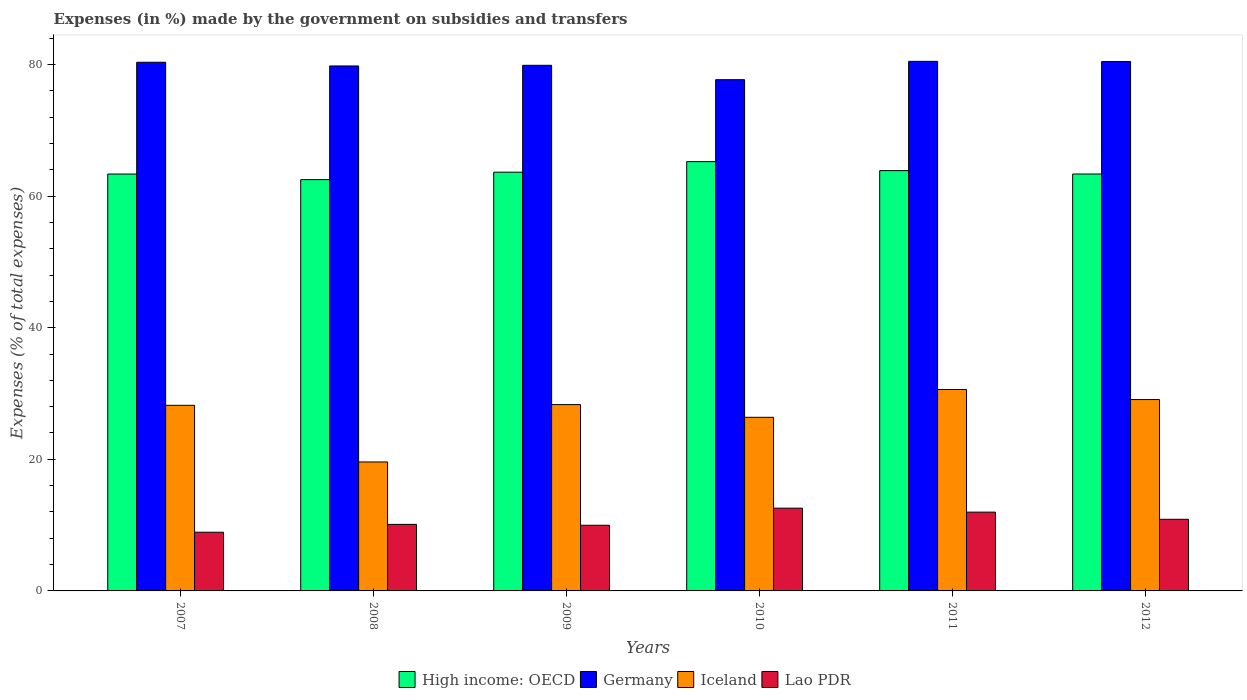How many different coloured bars are there?
Offer a terse response. 4. Are the number of bars on each tick of the X-axis equal?
Your answer should be compact. Yes. How many bars are there on the 1st tick from the right?
Provide a short and direct response. 4. What is the percentage of expenses made by the government on subsidies and transfers in Lao PDR in 2007?
Your response must be concise. 8.92. Across all years, what is the maximum percentage of expenses made by the government on subsidies and transfers in Lao PDR?
Offer a very short reply. 12.58. Across all years, what is the minimum percentage of expenses made by the government on subsidies and transfers in High income: OECD?
Give a very brief answer. 62.5. What is the total percentage of expenses made by the government on subsidies and transfers in High income: OECD in the graph?
Provide a short and direct response. 381.93. What is the difference between the percentage of expenses made by the government on subsidies and transfers in Germany in 2010 and that in 2012?
Your response must be concise. -2.76. What is the difference between the percentage of expenses made by the government on subsidies and transfers in High income: OECD in 2007 and the percentage of expenses made by the government on subsidies and transfers in Lao PDR in 2012?
Your answer should be very brief. 52.46. What is the average percentage of expenses made by the government on subsidies and transfers in Germany per year?
Offer a very short reply. 79.76. In the year 2011, what is the difference between the percentage of expenses made by the government on subsidies and transfers in Iceland and percentage of expenses made by the government on subsidies and transfers in Lao PDR?
Make the answer very short. 18.63. In how many years, is the percentage of expenses made by the government on subsidies and transfers in Iceland greater than 16 %?
Ensure brevity in your answer.  6. What is the ratio of the percentage of expenses made by the government on subsidies and transfers in High income: OECD in 2007 to that in 2011?
Offer a very short reply. 0.99. What is the difference between the highest and the second highest percentage of expenses made by the government on subsidies and transfers in High income: OECD?
Offer a terse response. 1.37. What is the difference between the highest and the lowest percentage of expenses made by the government on subsidies and transfers in High income: OECD?
Your answer should be very brief. 2.73. In how many years, is the percentage of expenses made by the government on subsidies and transfers in Germany greater than the average percentage of expenses made by the government on subsidies and transfers in Germany taken over all years?
Offer a terse response. 5. Is it the case that in every year, the sum of the percentage of expenses made by the government on subsidies and transfers in Iceland and percentage of expenses made by the government on subsidies and transfers in Lao PDR is greater than the sum of percentage of expenses made by the government on subsidies and transfers in Germany and percentage of expenses made by the government on subsidies and transfers in High income: OECD?
Keep it short and to the point. Yes. What does the 1st bar from the left in 2009 represents?
Provide a short and direct response. High income: OECD. What does the 4th bar from the right in 2008 represents?
Your response must be concise. High income: OECD. Is it the case that in every year, the sum of the percentage of expenses made by the government on subsidies and transfers in Germany and percentage of expenses made by the government on subsidies and transfers in Iceland is greater than the percentage of expenses made by the government on subsidies and transfers in High income: OECD?
Offer a terse response. Yes. How many years are there in the graph?
Provide a short and direct response. 6. What is the difference between two consecutive major ticks on the Y-axis?
Provide a succinct answer. 20. Are the values on the major ticks of Y-axis written in scientific E-notation?
Give a very brief answer. No. Does the graph contain any zero values?
Offer a very short reply. No. How are the legend labels stacked?
Keep it short and to the point. Horizontal. What is the title of the graph?
Keep it short and to the point. Expenses (in %) made by the government on subsidies and transfers. Does "Seychelles" appear as one of the legend labels in the graph?
Your response must be concise. No. What is the label or title of the Y-axis?
Provide a short and direct response. Expenses (% of total expenses). What is the Expenses (% of total expenses) in High income: OECD in 2007?
Your answer should be very brief. 63.35. What is the Expenses (% of total expenses) in Germany in 2007?
Your response must be concise. 80.33. What is the Expenses (% of total expenses) in Iceland in 2007?
Provide a short and direct response. 28.2. What is the Expenses (% of total expenses) in Lao PDR in 2007?
Provide a succinct answer. 8.92. What is the Expenses (% of total expenses) in High income: OECD in 2008?
Your answer should be compact. 62.5. What is the Expenses (% of total expenses) in Germany in 2008?
Provide a short and direct response. 79.77. What is the Expenses (% of total expenses) of Iceland in 2008?
Provide a succinct answer. 19.6. What is the Expenses (% of total expenses) in Lao PDR in 2008?
Your response must be concise. 10.11. What is the Expenses (% of total expenses) in High income: OECD in 2009?
Offer a terse response. 63.63. What is the Expenses (% of total expenses) of Germany in 2009?
Ensure brevity in your answer.  79.87. What is the Expenses (% of total expenses) in Iceland in 2009?
Give a very brief answer. 28.31. What is the Expenses (% of total expenses) of Lao PDR in 2009?
Your response must be concise. 9.98. What is the Expenses (% of total expenses) of High income: OECD in 2010?
Give a very brief answer. 65.23. What is the Expenses (% of total expenses) of Germany in 2010?
Offer a terse response. 77.69. What is the Expenses (% of total expenses) of Iceland in 2010?
Keep it short and to the point. 26.38. What is the Expenses (% of total expenses) of Lao PDR in 2010?
Your response must be concise. 12.58. What is the Expenses (% of total expenses) of High income: OECD in 2011?
Give a very brief answer. 63.87. What is the Expenses (% of total expenses) in Germany in 2011?
Provide a succinct answer. 80.47. What is the Expenses (% of total expenses) of Iceland in 2011?
Your answer should be very brief. 30.61. What is the Expenses (% of total expenses) in Lao PDR in 2011?
Offer a very short reply. 11.97. What is the Expenses (% of total expenses) of High income: OECD in 2012?
Provide a short and direct response. 63.35. What is the Expenses (% of total expenses) in Germany in 2012?
Offer a terse response. 80.44. What is the Expenses (% of total expenses) of Iceland in 2012?
Your answer should be compact. 29.08. What is the Expenses (% of total expenses) in Lao PDR in 2012?
Your answer should be very brief. 10.88. Across all years, what is the maximum Expenses (% of total expenses) in High income: OECD?
Make the answer very short. 65.23. Across all years, what is the maximum Expenses (% of total expenses) of Germany?
Make the answer very short. 80.47. Across all years, what is the maximum Expenses (% of total expenses) in Iceland?
Your response must be concise. 30.61. Across all years, what is the maximum Expenses (% of total expenses) in Lao PDR?
Offer a terse response. 12.58. Across all years, what is the minimum Expenses (% of total expenses) in High income: OECD?
Keep it short and to the point. 62.5. Across all years, what is the minimum Expenses (% of total expenses) of Germany?
Keep it short and to the point. 77.69. Across all years, what is the minimum Expenses (% of total expenses) in Iceland?
Provide a succinct answer. 19.6. Across all years, what is the minimum Expenses (% of total expenses) in Lao PDR?
Provide a short and direct response. 8.92. What is the total Expenses (% of total expenses) of High income: OECD in the graph?
Keep it short and to the point. 381.93. What is the total Expenses (% of total expenses) in Germany in the graph?
Offer a very short reply. 478.57. What is the total Expenses (% of total expenses) of Iceland in the graph?
Your answer should be compact. 162.18. What is the total Expenses (% of total expenses) in Lao PDR in the graph?
Provide a succinct answer. 64.44. What is the difference between the Expenses (% of total expenses) in High income: OECD in 2007 and that in 2008?
Your answer should be very brief. 0.85. What is the difference between the Expenses (% of total expenses) in Germany in 2007 and that in 2008?
Make the answer very short. 0.56. What is the difference between the Expenses (% of total expenses) of Iceland in 2007 and that in 2008?
Your response must be concise. 8.61. What is the difference between the Expenses (% of total expenses) of Lao PDR in 2007 and that in 2008?
Provide a succinct answer. -1.19. What is the difference between the Expenses (% of total expenses) of High income: OECD in 2007 and that in 2009?
Keep it short and to the point. -0.28. What is the difference between the Expenses (% of total expenses) of Germany in 2007 and that in 2009?
Keep it short and to the point. 0.46. What is the difference between the Expenses (% of total expenses) of Iceland in 2007 and that in 2009?
Provide a short and direct response. -0.11. What is the difference between the Expenses (% of total expenses) of Lao PDR in 2007 and that in 2009?
Keep it short and to the point. -1.06. What is the difference between the Expenses (% of total expenses) of High income: OECD in 2007 and that in 2010?
Ensure brevity in your answer.  -1.89. What is the difference between the Expenses (% of total expenses) of Germany in 2007 and that in 2010?
Make the answer very short. 2.65. What is the difference between the Expenses (% of total expenses) in Iceland in 2007 and that in 2010?
Keep it short and to the point. 1.82. What is the difference between the Expenses (% of total expenses) of Lao PDR in 2007 and that in 2010?
Offer a terse response. -3.66. What is the difference between the Expenses (% of total expenses) of High income: OECD in 2007 and that in 2011?
Keep it short and to the point. -0.52. What is the difference between the Expenses (% of total expenses) of Germany in 2007 and that in 2011?
Make the answer very short. -0.14. What is the difference between the Expenses (% of total expenses) of Iceland in 2007 and that in 2011?
Provide a short and direct response. -2.4. What is the difference between the Expenses (% of total expenses) in Lao PDR in 2007 and that in 2011?
Your response must be concise. -3.05. What is the difference between the Expenses (% of total expenses) in High income: OECD in 2007 and that in 2012?
Provide a short and direct response. -0.01. What is the difference between the Expenses (% of total expenses) of Germany in 2007 and that in 2012?
Your answer should be compact. -0.11. What is the difference between the Expenses (% of total expenses) in Iceland in 2007 and that in 2012?
Your response must be concise. -0.88. What is the difference between the Expenses (% of total expenses) of Lao PDR in 2007 and that in 2012?
Make the answer very short. -1.97. What is the difference between the Expenses (% of total expenses) in High income: OECD in 2008 and that in 2009?
Your answer should be compact. -1.13. What is the difference between the Expenses (% of total expenses) in Germany in 2008 and that in 2009?
Give a very brief answer. -0.1. What is the difference between the Expenses (% of total expenses) of Iceland in 2008 and that in 2009?
Your response must be concise. -8.72. What is the difference between the Expenses (% of total expenses) of Lao PDR in 2008 and that in 2009?
Your answer should be compact. 0.13. What is the difference between the Expenses (% of total expenses) in High income: OECD in 2008 and that in 2010?
Keep it short and to the point. -2.73. What is the difference between the Expenses (% of total expenses) of Germany in 2008 and that in 2010?
Make the answer very short. 2.08. What is the difference between the Expenses (% of total expenses) of Iceland in 2008 and that in 2010?
Give a very brief answer. -6.79. What is the difference between the Expenses (% of total expenses) in Lao PDR in 2008 and that in 2010?
Ensure brevity in your answer.  -2.46. What is the difference between the Expenses (% of total expenses) of High income: OECD in 2008 and that in 2011?
Keep it short and to the point. -1.37. What is the difference between the Expenses (% of total expenses) in Germany in 2008 and that in 2011?
Provide a succinct answer. -0.7. What is the difference between the Expenses (% of total expenses) in Iceland in 2008 and that in 2011?
Offer a terse response. -11.01. What is the difference between the Expenses (% of total expenses) in Lao PDR in 2008 and that in 2011?
Offer a very short reply. -1.86. What is the difference between the Expenses (% of total expenses) in High income: OECD in 2008 and that in 2012?
Provide a succinct answer. -0.85. What is the difference between the Expenses (% of total expenses) of Germany in 2008 and that in 2012?
Ensure brevity in your answer.  -0.67. What is the difference between the Expenses (% of total expenses) in Iceland in 2008 and that in 2012?
Provide a short and direct response. -9.48. What is the difference between the Expenses (% of total expenses) of Lao PDR in 2008 and that in 2012?
Your answer should be compact. -0.77. What is the difference between the Expenses (% of total expenses) of High income: OECD in 2009 and that in 2010?
Your answer should be very brief. -1.6. What is the difference between the Expenses (% of total expenses) in Germany in 2009 and that in 2010?
Give a very brief answer. 2.18. What is the difference between the Expenses (% of total expenses) of Iceland in 2009 and that in 2010?
Ensure brevity in your answer.  1.93. What is the difference between the Expenses (% of total expenses) in Lao PDR in 2009 and that in 2010?
Your answer should be very brief. -2.6. What is the difference between the Expenses (% of total expenses) of High income: OECD in 2009 and that in 2011?
Provide a short and direct response. -0.24. What is the difference between the Expenses (% of total expenses) in Germany in 2009 and that in 2011?
Ensure brevity in your answer.  -0.6. What is the difference between the Expenses (% of total expenses) of Iceland in 2009 and that in 2011?
Your response must be concise. -2.29. What is the difference between the Expenses (% of total expenses) of Lao PDR in 2009 and that in 2011?
Offer a very short reply. -1.99. What is the difference between the Expenses (% of total expenses) of High income: OECD in 2009 and that in 2012?
Make the answer very short. 0.28. What is the difference between the Expenses (% of total expenses) in Germany in 2009 and that in 2012?
Give a very brief answer. -0.57. What is the difference between the Expenses (% of total expenses) of Iceland in 2009 and that in 2012?
Ensure brevity in your answer.  -0.77. What is the difference between the Expenses (% of total expenses) in Lao PDR in 2009 and that in 2012?
Your answer should be very brief. -0.91. What is the difference between the Expenses (% of total expenses) in High income: OECD in 2010 and that in 2011?
Give a very brief answer. 1.37. What is the difference between the Expenses (% of total expenses) of Germany in 2010 and that in 2011?
Offer a terse response. -2.78. What is the difference between the Expenses (% of total expenses) in Iceland in 2010 and that in 2011?
Ensure brevity in your answer.  -4.22. What is the difference between the Expenses (% of total expenses) in Lao PDR in 2010 and that in 2011?
Your answer should be compact. 0.6. What is the difference between the Expenses (% of total expenses) in High income: OECD in 2010 and that in 2012?
Provide a succinct answer. 1.88. What is the difference between the Expenses (% of total expenses) in Germany in 2010 and that in 2012?
Offer a very short reply. -2.76. What is the difference between the Expenses (% of total expenses) of Iceland in 2010 and that in 2012?
Give a very brief answer. -2.7. What is the difference between the Expenses (% of total expenses) in Lao PDR in 2010 and that in 2012?
Provide a succinct answer. 1.69. What is the difference between the Expenses (% of total expenses) in High income: OECD in 2011 and that in 2012?
Your response must be concise. 0.51. What is the difference between the Expenses (% of total expenses) in Germany in 2011 and that in 2012?
Give a very brief answer. 0.03. What is the difference between the Expenses (% of total expenses) of Iceland in 2011 and that in 2012?
Provide a short and direct response. 1.53. What is the difference between the Expenses (% of total expenses) in Lao PDR in 2011 and that in 2012?
Provide a short and direct response. 1.09. What is the difference between the Expenses (% of total expenses) in High income: OECD in 2007 and the Expenses (% of total expenses) in Germany in 2008?
Provide a succinct answer. -16.42. What is the difference between the Expenses (% of total expenses) in High income: OECD in 2007 and the Expenses (% of total expenses) in Iceland in 2008?
Make the answer very short. 43.75. What is the difference between the Expenses (% of total expenses) in High income: OECD in 2007 and the Expenses (% of total expenses) in Lao PDR in 2008?
Your answer should be compact. 53.23. What is the difference between the Expenses (% of total expenses) of Germany in 2007 and the Expenses (% of total expenses) of Iceland in 2008?
Offer a very short reply. 60.74. What is the difference between the Expenses (% of total expenses) in Germany in 2007 and the Expenses (% of total expenses) in Lao PDR in 2008?
Give a very brief answer. 70.22. What is the difference between the Expenses (% of total expenses) of Iceland in 2007 and the Expenses (% of total expenses) of Lao PDR in 2008?
Your response must be concise. 18.09. What is the difference between the Expenses (% of total expenses) in High income: OECD in 2007 and the Expenses (% of total expenses) in Germany in 2009?
Make the answer very short. -16.52. What is the difference between the Expenses (% of total expenses) in High income: OECD in 2007 and the Expenses (% of total expenses) in Iceland in 2009?
Your response must be concise. 35.03. What is the difference between the Expenses (% of total expenses) of High income: OECD in 2007 and the Expenses (% of total expenses) of Lao PDR in 2009?
Ensure brevity in your answer.  53.37. What is the difference between the Expenses (% of total expenses) in Germany in 2007 and the Expenses (% of total expenses) in Iceland in 2009?
Offer a very short reply. 52.02. What is the difference between the Expenses (% of total expenses) in Germany in 2007 and the Expenses (% of total expenses) in Lao PDR in 2009?
Ensure brevity in your answer.  70.35. What is the difference between the Expenses (% of total expenses) in Iceland in 2007 and the Expenses (% of total expenses) in Lao PDR in 2009?
Offer a terse response. 18.22. What is the difference between the Expenses (% of total expenses) of High income: OECD in 2007 and the Expenses (% of total expenses) of Germany in 2010?
Ensure brevity in your answer.  -14.34. What is the difference between the Expenses (% of total expenses) of High income: OECD in 2007 and the Expenses (% of total expenses) of Iceland in 2010?
Your answer should be very brief. 36.96. What is the difference between the Expenses (% of total expenses) of High income: OECD in 2007 and the Expenses (% of total expenses) of Lao PDR in 2010?
Provide a succinct answer. 50.77. What is the difference between the Expenses (% of total expenses) of Germany in 2007 and the Expenses (% of total expenses) of Iceland in 2010?
Your answer should be compact. 53.95. What is the difference between the Expenses (% of total expenses) in Germany in 2007 and the Expenses (% of total expenses) in Lao PDR in 2010?
Your answer should be compact. 67.76. What is the difference between the Expenses (% of total expenses) of Iceland in 2007 and the Expenses (% of total expenses) of Lao PDR in 2010?
Make the answer very short. 15.63. What is the difference between the Expenses (% of total expenses) of High income: OECD in 2007 and the Expenses (% of total expenses) of Germany in 2011?
Keep it short and to the point. -17.12. What is the difference between the Expenses (% of total expenses) of High income: OECD in 2007 and the Expenses (% of total expenses) of Iceland in 2011?
Your response must be concise. 32.74. What is the difference between the Expenses (% of total expenses) of High income: OECD in 2007 and the Expenses (% of total expenses) of Lao PDR in 2011?
Offer a terse response. 51.37. What is the difference between the Expenses (% of total expenses) in Germany in 2007 and the Expenses (% of total expenses) in Iceland in 2011?
Provide a short and direct response. 49.73. What is the difference between the Expenses (% of total expenses) in Germany in 2007 and the Expenses (% of total expenses) in Lao PDR in 2011?
Offer a terse response. 68.36. What is the difference between the Expenses (% of total expenses) in Iceland in 2007 and the Expenses (% of total expenses) in Lao PDR in 2011?
Ensure brevity in your answer.  16.23. What is the difference between the Expenses (% of total expenses) in High income: OECD in 2007 and the Expenses (% of total expenses) in Germany in 2012?
Provide a succinct answer. -17.1. What is the difference between the Expenses (% of total expenses) in High income: OECD in 2007 and the Expenses (% of total expenses) in Iceland in 2012?
Your response must be concise. 34.27. What is the difference between the Expenses (% of total expenses) of High income: OECD in 2007 and the Expenses (% of total expenses) of Lao PDR in 2012?
Provide a succinct answer. 52.46. What is the difference between the Expenses (% of total expenses) in Germany in 2007 and the Expenses (% of total expenses) in Iceland in 2012?
Provide a short and direct response. 51.25. What is the difference between the Expenses (% of total expenses) in Germany in 2007 and the Expenses (% of total expenses) in Lao PDR in 2012?
Your answer should be compact. 69.45. What is the difference between the Expenses (% of total expenses) in Iceland in 2007 and the Expenses (% of total expenses) in Lao PDR in 2012?
Your answer should be compact. 17.32. What is the difference between the Expenses (% of total expenses) of High income: OECD in 2008 and the Expenses (% of total expenses) of Germany in 2009?
Make the answer very short. -17.37. What is the difference between the Expenses (% of total expenses) of High income: OECD in 2008 and the Expenses (% of total expenses) of Iceland in 2009?
Provide a succinct answer. 34.19. What is the difference between the Expenses (% of total expenses) in High income: OECD in 2008 and the Expenses (% of total expenses) in Lao PDR in 2009?
Keep it short and to the point. 52.52. What is the difference between the Expenses (% of total expenses) in Germany in 2008 and the Expenses (% of total expenses) in Iceland in 2009?
Provide a short and direct response. 51.46. What is the difference between the Expenses (% of total expenses) of Germany in 2008 and the Expenses (% of total expenses) of Lao PDR in 2009?
Provide a succinct answer. 69.79. What is the difference between the Expenses (% of total expenses) of Iceland in 2008 and the Expenses (% of total expenses) of Lao PDR in 2009?
Your answer should be compact. 9.62. What is the difference between the Expenses (% of total expenses) in High income: OECD in 2008 and the Expenses (% of total expenses) in Germany in 2010?
Ensure brevity in your answer.  -15.19. What is the difference between the Expenses (% of total expenses) in High income: OECD in 2008 and the Expenses (% of total expenses) in Iceland in 2010?
Provide a succinct answer. 36.12. What is the difference between the Expenses (% of total expenses) of High income: OECD in 2008 and the Expenses (% of total expenses) of Lao PDR in 2010?
Offer a very short reply. 49.92. What is the difference between the Expenses (% of total expenses) of Germany in 2008 and the Expenses (% of total expenses) of Iceland in 2010?
Provide a short and direct response. 53.39. What is the difference between the Expenses (% of total expenses) in Germany in 2008 and the Expenses (% of total expenses) in Lao PDR in 2010?
Offer a very short reply. 67.19. What is the difference between the Expenses (% of total expenses) in Iceland in 2008 and the Expenses (% of total expenses) in Lao PDR in 2010?
Offer a very short reply. 7.02. What is the difference between the Expenses (% of total expenses) in High income: OECD in 2008 and the Expenses (% of total expenses) in Germany in 2011?
Ensure brevity in your answer.  -17.97. What is the difference between the Expenses (% of total expenses) of High income: OECD in 2008 and the Expenses (% of total expenses) of Iceland in 2011?
Ensure brevity in your answer.  31.89. What is the difference between the Expenses (% of total expenses) in High income: OECD in 2008 and the Expenses (% of total expenses) in Lao PDR in 2011?
Provide a short and direct response. 50.53. What is the difference between the Expenses (% of total expenses) in Germany in 2008 and the Expenses (% of total expenses) in Iceland in 2011?
Offer a terse response. 49.16. What is the difference between the Expenses (% of total expenses) in Germany in 2008 and the Expenses (% of total expenses) in Lao PDR in 2011?
Provide a succinct answer. 67.8. What is the difference between the Expenses (% of total expenses) in Iceland in 2008 and the Expenses (% of total expenses) in Lao PDR in 2011?
Your response must be concise. 7.62. What is the difference between the Expenses (% of total expenses) in High income: OECD in 2008 and the Expenses (% of total expenses) in Germany in 2012?
Offer a very short reply. -17.94. What is the difference between the Expenses (% of total expenses) in High income: OECD in 2008 and the Expenses (% of total expenses) in Iceland in 2012?
Provide a short and direct response. 33.42. What is the difference between the Expenses (% of total expenses) of High income: OECD in 2008 and the Expenses (% of total expenses) of Lao PDR in 2012?
Provide a succinct answer. 51.62. What is the difference between the Expenses (% of total expenses) in Germany in 2008 and the Expenses (% of total expenses) in Iceland in 2012?
Offer a very short reply. 50.69. What is the difference between the Expenses (% of total expenses) of Germany in 2008 and the Expenses (% of total expenses) of Lao PDR in 2012?
Your answer should be compact. 68.89. What is the difference between the Expenses (% of total expenses) of Iceland in 2008 and the Expenses (% of total expenses) of Lao PDR in 2012?
Offer a very short reply. 8.71. What is the difference between the Expenses (% of total expenses) in High income: OECD in 2009 and the Expenses (% of total expenses) in Germany in 2010?
Keep it short and to the point. -14.06. What is the difference between the Expenses (% of total expenses) of High income: OECD in 2009 and the Expenses (% of total expenses) of Iceland in 2010?
Your answer should be compact. 37.25. What is the difference between the Expenses (% of total expenses) in High income: OECD in 2009 and the Expenses (% of total expenses) in Lao PDR in 2010?
Offer a very short reply. 51.05. What is the difference between the Expenses (% of total expenses) in Germany in 2009 and the Expenses (% of total expenses) in Iceland in 2010?
Your answer should be compact. 53.49. What is the difference between the Expenses (% of total expenses) in Germany in 2009 and the Expenses (% of total expenses) in Lao PDR in 2010?
Provide a short and direct response. 67.29. What is the difference between the Expenses (% of total expenses) of Iceland in 2009 and the Expenses (% of total expenses) of Lao PDR in 2010?
Make the answer very short. 15.74. What is the difference between the Expenses (% of total expenses) in High income: OECD in 2009 and the Expenses (% of total expenses) in Germany in 2011?
Your response must be concise. -16.84. What is the difference between the Expenses (% of total expenses) in High income: OECD in 2009 and the Expenses (% of total expenses) in Iceland in 2011?
Make the answer very short. 33.02. What is the difference between the Expenses (% of total expenses) in High income: OECD in 2009 and the Expenses (% of total expenses) in Lao PDR in 2011?
Give a very brief answer. 51.66. What is the difference between the Expenses (% of total expenses) of Germany in 2009 and the Expenses (% of total expenses) of Iceland in 2011?
Offer a terse response. 49.27. What is the difference between the Expenses (% of total expenses) of Germany in 2009 and the Expenses (% of total expenses) of Lao PDR in 2011?
Your answer should be very brief. 67.9. What is the difference between the Expenses (% of total expenses) of Iceland in 2009 and the Expenses (% of total expenses) of Lao PDR in 2011?
Make the answer very short. 16.34. What is the difference between the Expenses (% of total expenses) in High income: OECD in 2009 and the Expenses (% of total expenses) in Germany in 2012?
Make the answer very short. -16.81. What is the difference between the Expenses (% of total expenses) of High income: OECD in 2009 and the Expenses (% of total expenses) of Iceland in 2012?
Make the answer very short. 34.55. What is the difference between the Expenses (% of total expenses) in High income: OECD in 2009 and the Expenses (% of total expenses) in Lao PDR in 2012?
Give a very brief answer. 52.75. What is the difference between the Expenses (% of total expenses) in Germany in 2009 and the Expenses (% of total expenses) in Iceland in 2012?
Ensure brevity in your answer.  50.79. What is the difference between the Expenses (% of total expenses) of Germany in 2009 and the Expenses (% of total expenses) of Lao PDR in 2012?
Provide a short and direct response. 68.99. What is the difference between the Expenses (% of total expenses) in Iceland in 2009 and the Expenses (% of total expenses) in Lao PDR in 2012?
Your response must be concise. 17.43. What is the difference between the Expenses (% of total expenses) of High income: OECD in 2010 and the Expenses (% of total expenses) of Germany in 2011?
Your response must be concise. -15.24. What is the difference between the Expenses (% of total expenses) in High income: OECD in 2010 and the Expenses (% of total expenses) in Iceland in 2011?
Ensure brevity in your answer.  34.63. What is the difference between the Expenses (% of total expenses) in High income: OECD in 2010 and the Expenses (% of total expenses) in Lao PDR in 2011?
Offer a very short reply. 53.26. What is the difference between the Expenses (% of total expenses) of Germany in 2010 and the Expenses (% of total expenses) of Iceland in 2011?
Offer a very short reply. 47.08. What is the difference between the Expenses (% of total expenses) of Germany in 2010 and the Expenses (% of total expenses) of Lao PDR in 2011?
Your answer should be very brief. 65.72. What is the difference between the Expenses (% of total expenses) of Iceland in 2010 and the Expenses (% of total expenses) of Lao PDR in 2011?
Your response must be concise. 14.41. What is the difference between the Expenses (% of total expenses) in High income: OECD in 2010 and the Expenses (% of total expenses) in Germany in 2012?
Offer a very short reply. -15.21. What is the difference between the Expenses (% of total expenses) in High income: OECD in 2010 and the Expenses (% of total expenses) in Iceland in 2012?
Give a very brief answer. 36.15. What is the difference between the Expenses (% of total expenses) in High income: OECD in 2010 and the Expenses (% of total expenses) in Lao PDR in 2012?
Offer a terse response. 54.35. What is the difference between the Expenses (% of total expenses) in Germany in 2010 and the Expenses (% of total expenses) in Iceland in 2012?
Offer a very short reply. 48.61. What is the difference between the Expenses (% of total expenses) in Germany in 2010 and the Expenses (% of total expenses) in Lao PDR in 2012?
Your answer should be very brief. 66.8. What is the difference between the Expenses (% of total expenses) of Iceland in 2010 and the Expenses (% of total expenses) of Lao PDR in 2012?
Provide a short and direct response. 15.5. What is the difference between the Expenses (% of total expenses) of High income: OECD in 2011 and the Expenses (% of total expenses) of Germany in 2012?
Give a very brief answer. -16.58. What is the difference between the Expenses (% of total expenses) of High income: OECD in 2011 and the Expenses (% of total expenses) of Iceland in 2012?
Make the answer very short. 34.79. What is the difference between the Expenses (% of total expenses) in High income: OECD in 2011 and the Expenses (% of total expenses) in Lao PDR in 2012?
Your answer should be very brief. 52.98. What is the difference between the Expenses (% of total expenses) of Germany in 2011 and the Expenses (% of total expenses) of Iceland in 2012?
Keep it short and to the point. 51.39. What is the difference between the Expenses (% of total expenses) in Germany in 2011 and the Expenses (% of total expenses) in Lao PDR in 2012?
Make the answer very short. 69.59. What is the difference between the Expenses (% of total expenses) in Iceland in 2011 and the Expenses (% of total expenses) in Lao PDR in 2012?
Your response must be concise. 19.72. What is the average Expenses (% of total expenses) in High income: OECD per year?
Your response must be concise. 63.65. What is the average Expenses (% of total expenses) of Germany per year?
Keep it short and to the point. 79.76. What is the average Expenses (% of total expenses) in Iceland per year?
Your answer should be compact. 27.03. What is the average Expenses (% of total expenses) in Lao PDR per year?
Keep it short and to the point. 10.74. In the year 2007, what is the difference between the Expenses (% of total expenses) of High income: OECD and Expenses (% of total expenses) of Germany?
Your answer should be very brief. -16.99. In the year 2007, what is the difference between the Expenses (% of total expenses) in High income: OECD and Expenses (% of total expenses) in Iceland?
Provide a succinct answer. 35.14. In the year 2007, what is the difference between the Expenses (% of total expenses) in High income: OECD and Expenses (% of total expenses) in Lao PDR?
Provide a short and direct response. 54.43. In the year 2007, what is the difference between the Expenses (% of total expenses) of Germany and Expenses (% of total expenses) of Iceland?
Your response must be concise. 52.13. In the year 2007, what is the difference between the Expenses (% of total expenses) of Germany and Expenses (% of total expenses) of Lao PDR?
Your answer should be compact. 71.41. In the year 2007, what is the difference between the Expenses (% of total expenses) of Iceland and Expenses (% of total expenses) of Lao PDR?
Provide a short and direct response. 19.28. In the year 2008, what is the difference between the Expenses (% of total expenses) in High income: OECD and Expenses (% of total expenses) in Germany?
Your response must be concise. -17.27. In the year 2008, what is the difference between the Expenses (% of total expenses) in High income: OECD and Expenses (% of total expenses) in Iceland?
Keep it short and to the point. 42.9. In the year 2008, what is the difference between the Expenses (% of total expenses) of High income: OECD and Expenses (% of total expenses) of Lao PDR?
Make the answer very short. 52.39. In the year 2008, what is the difference between the Expenses (% of total expenses) of Germany and Expenses (% of total expenses) of Iceland?
Offer a very short reply. 60.17. In the year 2008, what is the difference between the Expenses (% of total expenses) in Germany and Expenses (% of total expenses) in Lao PDR?
Give a very brief answer. 69.66. In the year 2008, what is the difference between the Expenses (% of total expenses) in Iceland and Expenses (% of total expenses) in Lao PDR?
Provide a succinct answer. 9.48. In the year 2009, what is the difference between the Expenses (% of total expenses) in High income: OECD and Expenses (% of total expenses) in Germany?
Provide a short and direct response. -16.24. In the year 2009, what is the difference between the Expenses (% of total expenses) of High income: OECD and Expenses (% of total expenses) of Iceland?
Your response must be concise. 35.32. In the year 2009, what is the difference between the Expenses (% of total expenses) in High income: OECD and Expenses (% of total expenses) in Lao PDR?
Your answer should be compact. 53.65. In the year 2009, what is the difference between the Expenses (% of total expenses) in Germany and Expenses (% of total expenses) in Iceland?
Ensure brevity in your answer.  51.56. In the year 2009, what is the difference between the Expenses (% of total expenses) of Germany and Expenses (% of total expenses) of Lao PDR?
Offer a terse response. 69.89. In the year 2009, what is the difference between the Expenses (% of total expenses) of Iceland and Expenses (% of total expenses) of Lao PDR?
Provide a short and direct response. 18.33. In the year 2010, what is the difference between the Expenses (% of total expenses) in High income: OECD and Expenses (% of total expenses) in Germany?
Offer a terse response. -12.45. In the year 2010, what is the difference between the Expenses (% of total expenses) in High income: OECD and Expenses (% of total expenses) in Iceland?
Your answer should be very brief. 38.85. In the year 2010, what is the difference between the Expenses (% of total expenses) of High income: OECD and Expenses (% of total expenses) of Lao PDR?
Your answer should be compact. 52.66. In the year 2010, what is the difference between the Expenses (% of total expenses) in Germany and Expenses (% of total expenses) in Iceland?
Provide a short and direct response. 51.31. In the year 2010, what is the difference between the Expenses (% of total expenses) of Germany and Expenses (% of total expenses) of Lao PDR?
Your response must be concise. 65.11. In the year 2010, what is the difference between the Expenses (% of total expenses) in Iceland and Expenses (% of total expenses) in Lao PDR?
Offer a very short reply. 13.81. In the year 2011, what is the difference between the Expenses (% of total expenses) of High income: OECD and Expenses (% of total expenses) of Germany?
Your response must be concise. -16.6. In the year 2011, what is the difference between the Expenses (% of total expenses) of High income: OECD and Expenses (% of total expenses) of Iceland?
Your answer should be very brief. 33.26. In the year 2011, what is the difference between the Expenses (% of total expenses) in High income: OECD and Expenses (% of total expenses) in Lao PDR?
Offer a very short reply. 51.89. In the year 2011, what is the difference between the Expenses (% of total expenses) of Germany and Expenses (% of total expenses) of Iceland?
Your response must be concise. 49.87. In the year 2011, what is the difference between the Expenses (% of total expenses) of Germany and Expenses (% of total expenses) of Lao PDR?
Your answer should be very brief. 68.5. In the year 2011, what is the difference between the Expenses (% of total expenses) of Iceland and Expenses (% of total expenses) of Lao PDR?
Provide a short and direct response. 18.63. In the year 2012, what is the difference between the Expenses (% of total expenses) of High income: OECD and Expenses (% of total expenses) of Germany?
Ensure brevity in your answer.  -17.09. In the year 2012, what is the difference between the Expenses (% of total expenses) in High income: OECD and Expenses (% of total expenses) in Iceland?
Provide a succinct answer. 34.27. In the year 2012, what is the difference between the Expenses (% of total expenses) of High income: OECD and Expenses (% of total expenses) of Lao PDR?
Make the answer very short. 52.47. In the year 2012, what is the difference between the Expenses (% of total expenses) of Germany and Expenses (% of total expenses) of Iceland?
Your answer should be very brief. 51.37. In the year 2012, what is the difference between the Expenses (% of total expenses) in Germany and Expenses (% of total expenses) in Lao PDR?
Your answer should be very brief. 69.56. In the year 2012, what is the difference between the Expenses (% of total expenses) of Iceland and Expenses (% of total expenses) of Lao PDR?
Ensure brevity in your answer.  18.19. What is the ratio of the Expenses (% of total expenses) in High income: OECD in 2007 to that in 2008?
Offer a terse response. 1.01. What is the ratio of the Expenses (% of total expenses) in Germany in 2007 to that in 2008?
Provide a short and direct response. 1.01. What is the ratio of the Expenses (% of total expenses) of Iceland in 2007 to that in 2008?
Offer a very short reply. 1.44. What is the ratio of the Expenses (% of total expenses) of Lao PDR in 2007 to that in 2008?
Make the answer very short. 0.88. What is the ratio of the Expenses (% of total expenses) of Germany in 2007 to that in 2009?
Ensure brevity in your answer.  1.01. What is the ratio of the Expenses (% of total expenses) of Iceland in 2007 to that in 2009?
Your response must be concise. 1. What is the ratio of the Expenses (% of total expenses) of Lao PDR in 2007 to that in 2009?
Ensure brevity in your answer.  0.89. What is the ratio of the Expenses (% of total expenses) of High income: OECD in 2007 to that in 2010?
Make the answer very short. 0.97. What is the ratio of the Expenses (% of total expenses) of Germany in 2007 to that in 2010?
Offer a terse response. 1.03. What is the ratio of the Expenses (% of total expenses) of Iceland in 2007 to that in 2010?
Your response must be concise. 1.07. What is the ratio of the Expenses (% of total expenses) in Lao PDR in 2007 to that in 2010?
Make the answer very short. 0.71. What is the ratio of the Expenses (% of total expenses) of Iceland in 2007 to that in 2011?
Your answer should be very brief. 0.92. What is the ratio of the Expenses (% of total expenses) in Lao PDR in 2007 to that in 2011?
Your answer should be compact. 0.74. What is the ratio of the Expenses (% of total expenses) in High income: OECD in 2007 to that in 2012?
Provide a succinct answer. 1. What is the ratio of the Expenses (% of total expenses) of Germany in 2007 to that in 2012?
Offer a terse response. 1. What is the ratio of the Expenses (% of total expenses) of Iceland in 2007 to that in 2012?
Give a very brief answer. 0.97. What is the ratio of the Expenses (% of total expenses) in Lao PDR in 2007 to that in 2012?
Keep it short and to the point. 0.82. What is the ratio of the Expenses (% of total expenses) of High income: OECD in 2008 to that in 2009?
Offer a very short reply. 0.98. What is the ratio of the Expenses (% of total expenses) of Iceland in 2008 to that in 2009?
Ensure brevity in your answer.  0.69. What is the ratio of the Expenses (% of total expenses) of Lao PDR in 2008 to that in 2009?
Offer a terse response. 1.01. What is the ratio of the Expenses (% of total expenses) of High income: OECD in 2008 to that in 2010?
Make the answer very short. 0.96. What is the ratio of the Expenses (% of total expenses) of Germany in 2008 to that in 2010?
Keep it short and to the point. 1.03. What is the ratio of the Expenses (% of total expenses) of Iceland in 2008 to that in 2010?
Keep it short and to the point. 0.74. What is the ratio of the Expenses (% of total expenses) in Lao PDR in 2008 to that in 2010?
Your answer should be compact. 0.8. What is the ratio of the Expenses (% of total expenses) in High income: OECD in 2008 to that in 2011?
Provide a succinct answer. 0.98. What is the ratio of the Expenses (% of total expenses) of Iceland in 2008 to that in 2011?
Provide a short and direct response. 0.64. What is the ratio of the Expenses (% of total expenses) of Lao PDR in 2008 to that in 2011?
Provide a short and direct response. 0.84. What is the ratio of the Expenses (% of total expenses) of High income: OECD in 2008 to that in 2012?
Keep it short and to the point. 0.99. What is the ratio of the Expenses (% of total expenses) of Germany in 2008 to that in 2012?
Your answer should be very brief. 0.99. What is the ratio of the Expenses (% of total expenses) of Iceland in 2008 to that in 2012?
Make the answer very short. 0.67. What is the ratio of the Expenses (% of total expenses) in Lao PDR in 2008 to that in 2012?
Keep it short and to the point. 0.93. What is the ratio of the Expenses (% of total expenses) of High income: OECD in 2009 to that in 2010?
Ensure brevity in your answer.  0.98. What is the ratio of the Expenses (% of total expenses) in Germany in 2009 to that in 2010?
Provide a succinct answer. 1.03. What is the ratio of the Expenses (% of total expenses) in Iceland in 2009 to that in 2010?
Offer a very short reply. 1.07. What is the ratio of the Expenses (% of total expenses) in Lao PDR in 2009 to that in 2010?
Keep it short and to the point. 0.79. What is the ratio of the Expenses (% of total expenses) in Germany in 2009 to that in 2011?
Your answer should be compact. 0.99. What is the ratio of the Expenses (% of total expenses) in Iceland in 2009 to that in 2011?
Your response must be concise. 0.93. What is the ratio of the Expenses (% of total expenses) of Lao PDR in 2009 to that in 2011?
Your response must be concise. 0.83. What is the ratio of the Expenses (% of total expenses) of High income: OECD in 2009 to that in 2012?
Your answer should be very brief. 1. What is the ratio of the Expenses (% of total expenses) of Germany in 2009 to that in 2012?
Offer a very short reply. 0.99. What is the ratio of the Expenses (% of total expenses) of Iceland in 2009 to that in 2012?
Offer a terse response. 0.97. What is the ratio of the Expenses (% of total expenses) in Lao PDR in 2009 to that in 2012?
Offer a very short reply. 0.92. What is the ratio of the Expenses (% of total expenses) of High income: OECD in 2010 to that in 2011?
Provide a succinct answer. 1.02. What is the ratio of the Expenses (% of total expenses) of Germany in 2010 to that in 2011?
Keep it short and to the point. 0.97. What is the ratio of the Expenses (% of total expenses) of Iceland in 2010 to that in 2011?
Offer a terse response. 0.86. What is the ratio of the Expenses (% of total expenses) in Lao PDR in 2010 to that in 2011?
Provide a succinct answer. 1.05. What is the ratio of the Expenses (% of total expenses) in High income: OECD in 2010 to that in 2012?
Keep it short and to the point. 1.03. What is the ratio of the Expenses (% of total expenses) in Germany in 2010 to that in 2012?
Your answer should be compact. 0.97. What is the ratio of the Expenses (% of total expenses) of Iceland in 2010 to that in 2012?
Offer a very short reply. 0.91. What is the ratio of the Expenses (% of total expenses) in Lao PDR in 2010 to that in 2012?
Give a very brief answer. 1.16. What is the ratio of the Expenses (% of total expenses) of Germany in 2011 to that in 2012?
Provide a short and direct response. 1. What is the ratio of the Expenses (% of total expenses) in Iceland in 2011 to that in 2012?
Offer a terse response. 1.05. What is the ratio of the Expenses (% of total expenses) of Lao PDR in 2011 to that in 2012?
Provide a short and direct response. 1.1. What is the difference between the highest and the second highest Expenses (% of total expenses) in High income: OECD?
Offer a very short reply. 1.37. What is the difference between the highest and the second highest Expenses (% of total expenses) in Germany?
Offer a very short reply. 0.03. What is the difference between the highest and the second highest Expenses (% of total expenses) in Iceland?
Your answer should be compact. 1.53. What is the difference between the highest and the second highest Expenses (% of total expenses) of Lao PDR?
Your answer should be compact. 0.6. What is the difference between the highest and the lowest Expenses (% of total expenses) of High income: OECD?
Offer a very short reply. 2.73. What is the difference between the highest and the lowest Expenses (% of total expenses) in Germany?
Your response must be concise. 2.78. What is the difference between the highest and the lowest Expenses (% of total expenses) in Iceland?
Your answer should be compact. 11.01. What is the difference between the highest and the lowest Expenses (% of total expenses) of Lao PDR?
Provide a short and direct response. 3.66. 